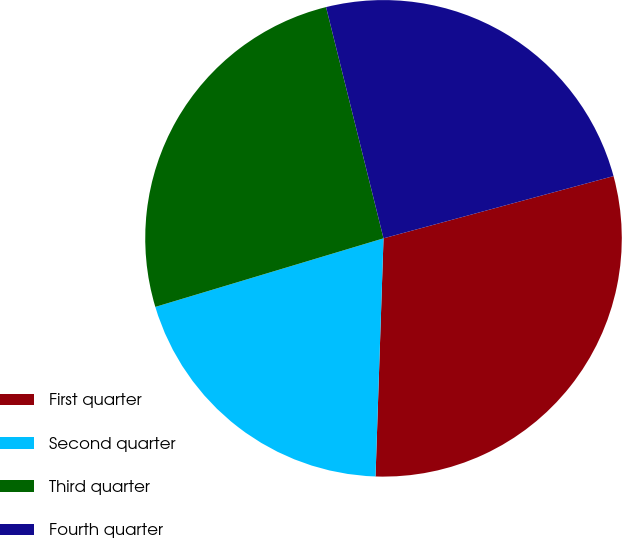<chart> <loc_0><loc_0><loc_500><loc_500><pie_chart><fcel>First quarter<fcel>Second quarter<fcel>Third quarter<fcel>Fourth quarter<nl><fcel>29.74%<fcel>19.82%<fcel>25.77%<fcel>24.67%<nl></chart> 